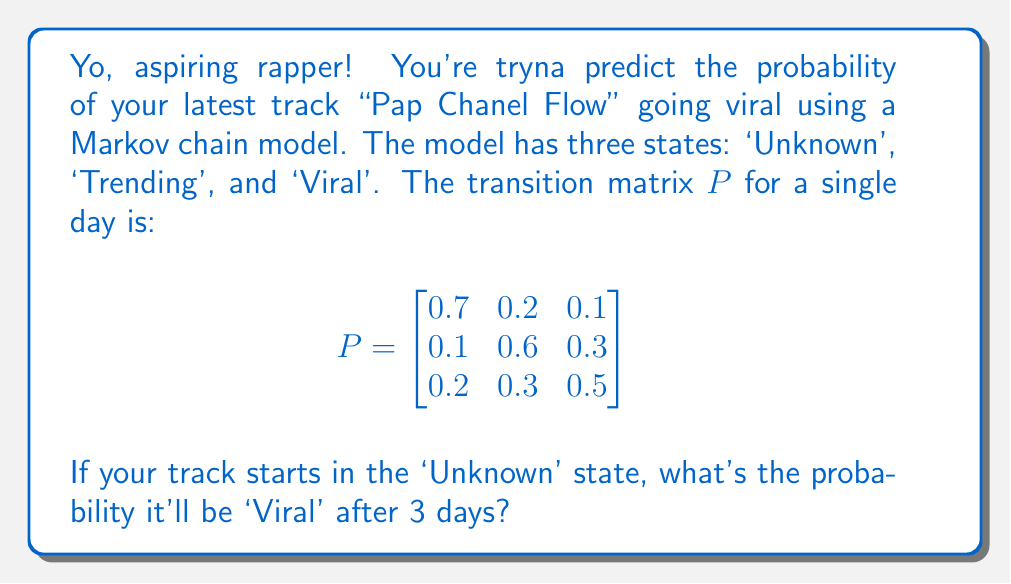Provide a solution to this math problem. Let's break this down step-by-step:

1) First, we need to calculate $P^3$, which represents the transition probabilities after 3 days. We can do this by multiplying $P$ by itself three times.

2) Using matrix multiplication (or a computer algebra system), we get:

   $$P^3 = \begin{bmatrix}
   0.412 & 0.324 & 0.264 \\
   0.293 & 0.366 & 0.341 \\
   0.331 & 0.354 & 0.315
   \end{bmatrix}$$

3) Now, we need to focus on the probability of going from 'Unknown' to 'Viral' in 3 days.

4) The initial state vector for 'Unknown' is $[1, 0, 0]$, as we start with 100% probability in the 'Unknown' state.

5) To find the probabilities after 3 days, we multiply this initial vector by $P^3$:

   $[1, 0, 0] \times \begin{bmatrix}
   0.412 & 0.324 & 0.264 \\
   0.293 & 0.366 & 0.341 \\
   0.331 & 0.354 & 0.315
   \end{bmatrix} = [0.412, 0.324, 0.264]$

6) The last element of this resulting vector, 0.264, represents the probability of being in the 'Viral' state after 3 days, starting from 'Unknown'.

Therefore, the probability that your track "Pap Chanel Flow" will be 'Viral' after 3 days, starting from 'Unknown', is 0.264 or 26.4%.
Answer: 0.264 